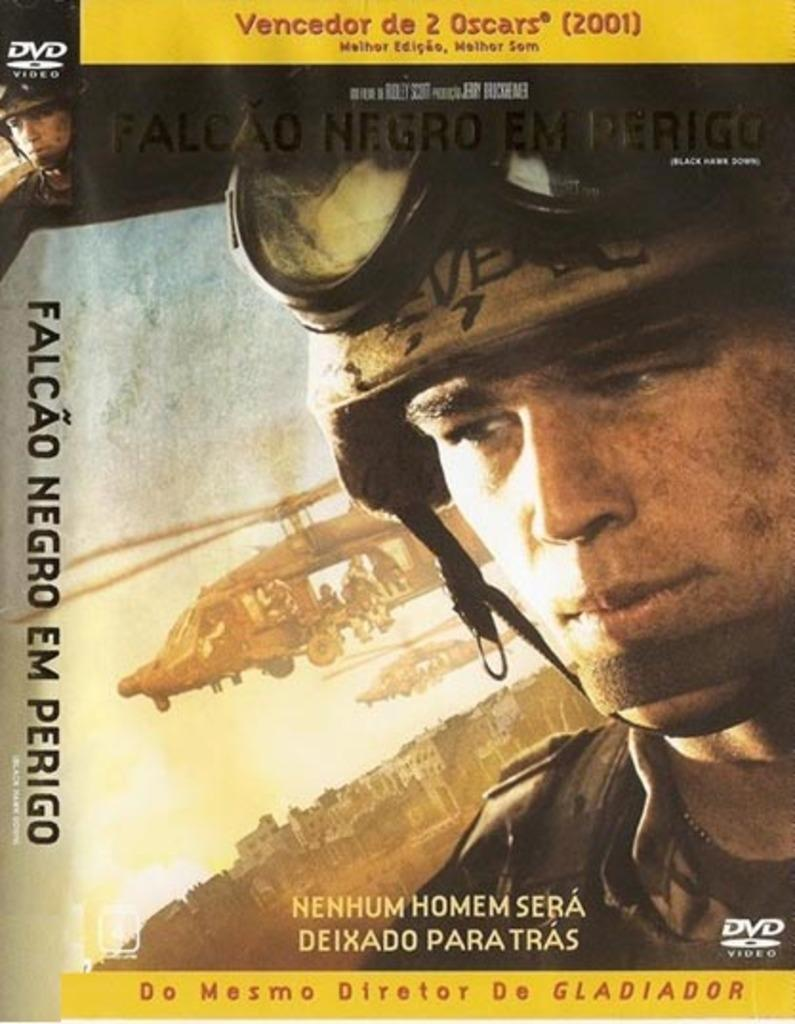<image>
Offer a succinct explanation of the picture presented. a dvd with 2 Oscars written at the top 